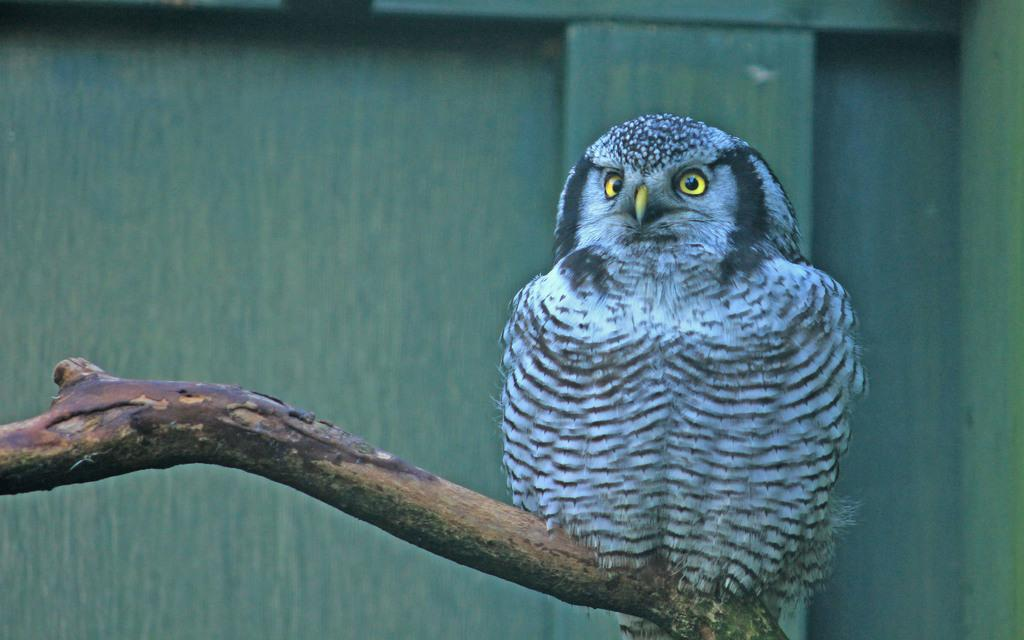What type of animal is in the image? There is an owl in the image. Where is the owl located? The owl is sitting on a branch of a tree. Can you identify any other structures or objects in the image? Yes, there is a door visible in the image. What team is the owl supporting in the image? There is no indication of a team or any sports-related activity in the image. 